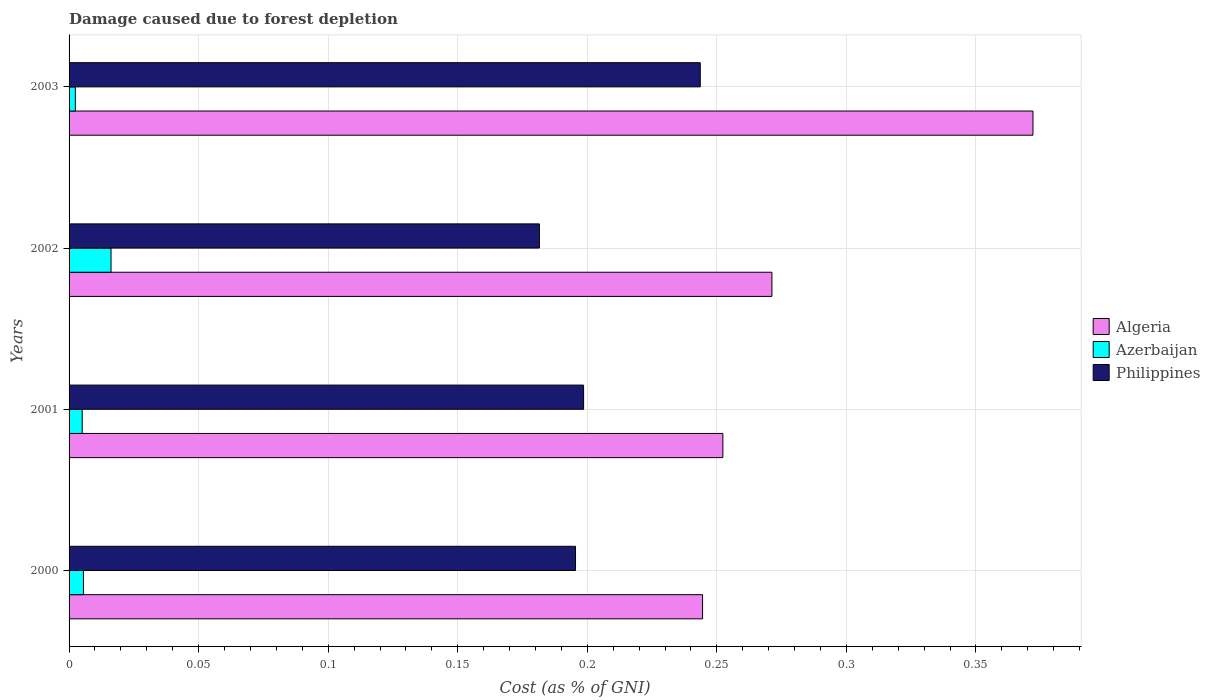How many different coloured bars are there?
Offer a terse response. 3. Are the number of bars per tick equal to the number of legend labels?
Keep it short and to the point. Yes. How many bars are there on the 4th tick from the top?
Your answer should be compact. 3. What is the label of the 1st group of bars from the top?
Offer a very short reply. 2003. What is the cost of damage caused due to forest depletion in Algeria in 2003?
Your response must be concise. 0.37. Across all years, what is the maximum cost of damage caused due to forest depletion in Philippines?
Your answer should be compact. 0.24. Across all years, what is the minimum cost of damage caused due to forest depletion in Philippines?
Ensure brevity in your answer.  0.18. In which year was the cost of damage caused due to forest depletion in Philippines maximum?
Offer a terse response. 2003. What is the total cost of damage caused due to forest depletion in Philippines in the graph?
Your answer should be compact. 0.82. What is the difference between the cost of damage caused due to forest depletion in Algeria in 2001 and that in 2003?
Offer a very short reply. -0.12. What is the difference between the cost of damage caused due to forest depletion in Philippines in 2001 and the cost of damage caused due to forest depletion in Algeria in 2002?
Make the answer very short. -0.07. What is the average cost of damage caused due to forest depletion in Algeria per year?
Provide a short and direct response. 0.29. In the year 2000, what is the difference between the cost of damage caused due to forest depletion in Algeria and cost of damage caused due to forest depletion in Philippines?
Your answer should be very brief. 0.05. What is the ratio of the cost of damage caused due to forest depletion in Algeria in 2001 to that in 2002?
Offer a terse response. 0.93. Is the cost of damage caused due to forest depletion in Philippines in 2001 less than that in 2003?
Give a very brief answer. Yes. Is the difference between the cost of damage caused due to forest depletion in Algeria in 2001 and 2002 greater than the difference between the cost of damage caused due to forest depletion in Philippines in 2001 and 2002?
Provide a succinct answer. No. What is the difference between the highest and the second highest cost of damage caused due to forest depletion in Algeria?
Provide a short and direct response. 0.1. What is the difference between the highest and the lowest cost of damage caused due to forest depletion in Azerbaijan?
Give a very brief answer. 0.01. In how many years, is the cost of damage caused due to forest depletion in Azerbaijan greater than the average cost of damage caused due to forest depletion in Azerbaijan taken over all years?
Offer a very short reply. 1. Is the sum of the cost of damage caused due to forest depletion in Philippines in 2000 and 2003 greater than the maximum cost of damage caused due to forest depletion in Azerbaijan across all years?
Provide a short and direct response. Yes. What does the 2nd bar from the top in 2001 represents?
Give a very brief answer. Azerbaijan. What does the 3rd bar from the bottom in 2003 represents?
Give a very brief answer. Philippines. How many bars are there?
Your response must be concise. 12. How many years are there in the graph?
Offer a terse response. 4. Are the values on the major ticks of X-axis written in scientific E-notation?
Your answer should be compact. No. Does the graph contain any zero values?
Ensure brevity in your answer.  No. Does the graph contain grids?
Your response must be concise. Yes. How many legend labels are there?
Give a very brief answer. 3. How are the legend labels stacked?
Ensure brevity in your answer.  Vertical. What is the title of the graph?
Provide a short and direct response. Damage caused due to forest depletion. Does "Low income" appear as one of the legend labels in the graph?
Keep it short and to the point. No. What is the label or title of the X-axis?
Provide a succinct answer. Cost (as % of GNI). What is the label or title of the Y-axis?
Offer a terse response. Years. What is the Cost (as % of GNI) in Algeria in 2000?
Provide a short and direct response. 0.24. What is the Cost (as % of GNI) in Azerbaijan in 2000?
Provide a succinct answer. 0.01. What is the Cost (as % of GNI) of Philippines in 2000?
Your answer should be compact. 0.2. What is the Cost (as % of GNI) in Algeria in 2001?
Your answer should be very brief. 0.25. What is the Cost (as % of GNI) in Azerbaijan in 2001?
Offer a very short reply. 0.01. What is the Cost (as % of GNI) in Philippines in 2001?
Your answer should be very brief. 0.2. What is the Cost (as % of GNI) of Algeria in 2002?
Your answer should be compact. 0.27. What is the Cost (as % of GNI) in Azerbaijan in 2002?
Give a very brief answer. 0.02. What is the Cost (as % of GNI) of Philippines in 2002?
Your answer should be compact. 0.18. What is the Cost (as % of GNI) of Algeria in 2003?
Give a very brief answer. 0.37. What is the Cost (as % of GNI) in Azerbaijan in 2003?
Your answer should be very brief. 0. What is the Cost (as % of GNI) of Philippines in 2003?
Your answer should be compact. 0.24. Across all years, what is the maximum Cost (as % of GNI) of Algeria?
Offer a very short reply. 0.37. Across all years, what is the maximum Cost (as % of GNI) in Azerbaijan?
Your response must be concise. 0.02. Across all years, what is the maximum Cost (as % of GNI) in Philippines?
Offer a terse response. 0.24. Across all years, what is the minimum Cost (as % of GNI) of Algeria?
Your answer should be compact. 0.24. Across all years, what is the minimum Cost (as % of GNI) of Azerbaijan?
Your answer should be compact. 0. Across all years, what is the minimum Cost (as % of GNI) in Philippines?
Offer a terse response. 0.18. What is the total Cost (as % of GNI) in Algeria in the graph?
Your response must be concise. 1.14. What is the total Cost (as % of GNI) in Azerbaijan in the graph?
Give a very brief answer. 0.03. What is the total Cost (as % of GNI) of Philippines in the graph?
Offer a very short reply. 0.82. What is the difference between the Cost (as % of GNI) of Algeria in 2000 and that in 2001?
Keep it short and to the point. -0.01. What is the difference between the Cost (as % of GNI) of Philippines in 2000 and that in 2001?
Ensure brevity in your answer.  -0. What is the difference between the Cost (as % of GNI) of Algeria in 2000 and that in 2002?
Give a very brief answer. -0.03. What is the difference between the Cost (as % of GNI) in Azerbaijan in 2000 and that in 2002?
Your answer should be compact. -0.01. What is the difference between the Cost (as % of GNI) in Philippines in 2000 and that in 2002?
Make the answer very short. 0.01. What is the difference between the Cost (as % of GNI) in Algeria in 2000 and that in 2003?
Provide a succinct answer. -0.13. What is the difference between the Cost (as % of GNI) in Azerbaijan in 2000 and that in 2003?
Offer a terse response. 0. What is the difference between the Cost (as % of GNI) of Philippines in 2000 and that in 2003?
Ensure brevity in your answer.  -0.05. What is the difference between the Cost (as % of GNI) in Algeria in 2001 and that in 2002?
Give a very brief answer. -0.02. What is the difference between the Cost (as % of GNI) in Azerbaijan in 2001 and that in 2002?
Your response must be concise. -0.01. What is the difference between the Cost (as % of GNI) of Philippines in 2001 and that in 2002?
Give a very brief answer. 0.02. What is the difference between the Cost (as % of GNI) of Algeria in 2001 and that in 2003?
Provide a succinct answer. -0.12. What is the difference between the Cost (as % of GNI) in Azerbaijan in 2001 and that in 2003?
Ensure brevity in your answer.  0. What is the difference between the Cost (as % of GNI) in Philippines in 2001 and that in 2003?
Offer a very short reply. -0.04. What is the difference between the Cost (as % of GNI) of Algeria in 2002 and that in 2003?
Your response must be concise. -0.1. What is the difference between the Cost (as % of GNI) in Azerbaijan in 2002 and that in 2003?
Your answer should be very brief. 0.01. What is the difference between the Cost (as % of GNI) in Philippines in 2002 and that in 2003?
Keep it short and to the point. -0.06. What is the difference between the Cost (as % of GNI) in Algeria in 2000 and the Cost (as % of GNI) in Azerbaijan in 2001?
Offer a very short reply. 0.24. What is the difference between the Cost (as % of GNI) of Algeria in 2000 and the Cost (as % of GNI) of Philippines in 2001?
Provide a succinct answer. 0.05. What is the difference between the Cost (as % of GNI) of Azerbaijan in 2000 and the Cost (as % of GNI) of Philippines in 2001?
Provide a succinct answer. -0.19. What is the difference between the Cost (as % of GNI) in Algeria in 2000 and the Cost (as % of GNI) in Azerbaijan in 2002?
Your response must be concise. 0.23. What is the difference between the Cost (as % of GNI) in Algeria in 2000 and the Cost (as % of GNI) in Philippines in 2002?
Ensure brevity in your answer.  0.06. What is the difference between the Cost (as % of GNI) of Azerbaijan in 2000 and the Cost (as % of GNI) of Philippines in 2002?
Make the answer very short. -0.18. What is the difference between the Cost (as % of GNI) in Algeria in 2000 and the Cost (as % of GNI) in Azerbaijan in 2003?
Provide a succinct answer. 0.24. What is the difference between the Cost (as % of GNI) of Algeria in 2000 and the Cost (as % of GNI) of Philippines in 2003?
Ensure brevity in your answer.  0. What is the difference between the Cost (as % of GNI) in Azerbaijan in 2000 and the Cost (as % of GNI) in Philippines in 2003?
Offer a very short reply. -0.24. What is the difference between the Cost (as % of GNI) in Algeria in 2001 and the Cost (as % of GNI) in Azerbaijan in 2002?
Keep it short and to the point. 0.24. What is the difference between the Cost (as % of GNI) of Algeria in 2001 and the Cost (as % of GNI) of Philippines in 2002?
Keep it short and to the point. 0.07. What is the difference between the Cost (as % of GNI) in Azerbaijan in 2001 and the Cost (as % of GNI) in Philippines in 2002?
Your answer should be compact. -0.18. What is the difference between the Cost (as % of GNI) in Algeria in 2001 and the Cost (as % of GNI) in Azerbaijan in 2003?
Give a very brief answer. 0.25. What is the difference between the Cost (as % of GNI) in Algeria in 2001 and the Cost (as % of GNI) in Philippines in 2003?
Your answer should be compact. 0.01. What is the difference between the Cost (as % of GNI) in Azerbaijan in 2001 and the Cost (as % of GNI) in Philippines in 2003?
Give a very brief answer. -0.24. What is the difference between the Cost (as % of GNI) in Algeria in 2002 and the Cost (as % of GNI) in Azerbaijan in 2003?
Offer a very short reply. 0.27. What is the difference between the Cost (as % of GNI) in Algeria in 2002 and the Cost (as % of GNI) in Philippines in 2003?
Offer a very short reply. 0.03. What is the difference between the Cost (as % of GNI) in Azerbaijan in 2002 and the Cost (as % of GNI) in Philippines in 2003?
Provide a short and direct response. -0.23. What is the average Cost (as % of GNI) of Algeria per year?
Make the answer very short. 0.28. What is the average Cost (as % of GNI) of Azerbaijan per year?
Offer a very short reply. 0.01. What is the average Cost (as % of GNI) of Philippines per year?
Make the answer very short. 0.2. In the year 2000, what is the difference between the Cost (as % of GNI) in Algeria and Cost (as % of GNI) in Azerbaijan?
Offer a terse response. 0.24. In the year 2000, what is the difference between the Cost (as % of GNI) in Algeria and Cost (as % of GNI) in Philippines?
Give a very brief answer. 0.05. In the year 2000, what is the difference between the Cost (as % of GNI) in Azerbaijan and Cost (as % of GNI) in Philippines?
Your answer should be very brief. -0.19. In the year 2001, what is the difference between the Cost (as % of GNI) of Algeria and Cost (as % of GNI) of Azerbaijan?
Give a very brief answer. 0.25. In the year 2001, what is the difference between the Cost (as % of GNI) in Algeria and Cost (as % of GNI) in Philippines?
Provide a succinct answer. 0.05. In the year 2001, what is the difference between the Cost (as % of GNI) in Azerbaijan and Cost (as % of GNI) in Philippines?
Provide a succinct answer. -0.19. In the year 2002, what is the difference between the Cost (as % of GNI) in Algeria and Cost (as % of GNI) in Azerbaijan?
Offer a very short reply. 0.26. In the year 2002, what is the difference between the Cost (as % of GNI) in Algeria and Cost (as % of GNI) in Philippines?
Your answer should be very brief. 0.09. In the year 2002, what is the difference between the Cost (as % of GNI) in Azerbaijan and Cost (as % of GNI) in Philippines?
Make the answer very short. -0.17. In the year 2003, what is the difference between the Cost (as % of GNI) in Algeria and Cost (as % of GNI) in Azerbaijan?
Your answer should be very brief. 0.37. In the year 2003, what is the difference between the Cost (as % of GNI) of Algeria and Cost (as % of GNI) of Philippines?
Make the answer very short. 0.13. In the year 2003, what is the difference between the Cost (as % of GNI) of Azerbaijan and Cost (as % of GNI) of Philippines?
Provide a short and direct response. -0.24. What is the ratio of the Cost (as % of GNI) of Algeria in 2000 to that in 2001?
Ensure brevity in your answer.  0.97. What is the ratio of the Cost (as % of GNI) of Azerbaijan in 2000 to that in 2001?
Make the answer very short. 1.09. What is the ratio of the Cost (as % of GNI) in Philippines in 2000 to that in 2001?
Provide a succinct answer. 0.98. What is the ratio of the Cost (as % of GNI) of Algeria in 2000 to that in 2002?
Make the answer very short. 0.9. What is the ratio of the Cost (as % of GNI) in Azerbaijan in 2000 to that in 2002?
Your answer should be very brief. 0.34. What is the ratio of the Cost (as % of GNI) of Algeria in 2000 to that in 2003?
Your answer should be very brief. 0.66. What is the ratio of the Cost (as % of GNI) of Azerbaijan in 2000 to that in 2003?
Offer a very short reply. 2.29. What is the ratio of the Cost (as % of GNI) in Philippines in 2000 to that in 2003?
Your response must be concise. 0.8. What is the ratio of the Cost (as % of GNI) in Algeria in 2001 to that in 2002?
Your answer should be compact. 0.93. What is the ratio of the Cost (as % of GNI) in Azerbaijan in 2001 to that in 2002?
Your answer should be compact. 0.31. What is the ratio of the Cost (as % of GNI) of Philippines in 2001 to that in 2002?
Provide a short and direct response. 1.09. What is the ratio of the Cost (as % of GNI) of Algeria in 2001 to that in 2003?
Give a very brief answer. 0.68. What is the ratio of the Cost (as % of GNI) in Azerbaijan in 2001 to that in 2003?
Ensure brevity in your answer.  2.09. What is the ratio of the Cost (as % of GNI) in Philippines in 2001 to that in 2003?
Provide a succinct answer. 0.82. What is the ratio of the Cost (as % of GNI) of Algeria in 2002 to that in 2003?
Your answer should be compact. 0.73. What is the ratio of the Cost (as % of GNI) of Azerbaijan in 2002 to that in 2003?
Your answer should be very brief. 6.68. What is the ratio of the Cost (as % of GNI) in Philippines in 2002 to that in 2003?
Offer a terse response. 0.75. What is the difference between the highest and the second highest Cost (as % of GNI) in Algeria?
Ensure brevity in your answer.  0.1. What is the difference between the highest and the second highest Cost (as % of GNI) in Azerbaijan?
Make the answer very short. 0.01. What is the difference between the highest and the second highest Cost (as % of GNI) in Philippines?
Ensure brevity in your answer.  0.04. What is the difference between the highest and the lowest Cost (as % of GNI) of Algeria?
Provide a short and direct response. 0.13. What is the difference between the highest and the lowest Cost (as % of GNI) in Azerbaijan?
Provide a short and direct response. 0.01. What is the difference between the highest and the lowest Cost (as % of GNI) in Philippines?
Keep it short and to the point. 0.06. 